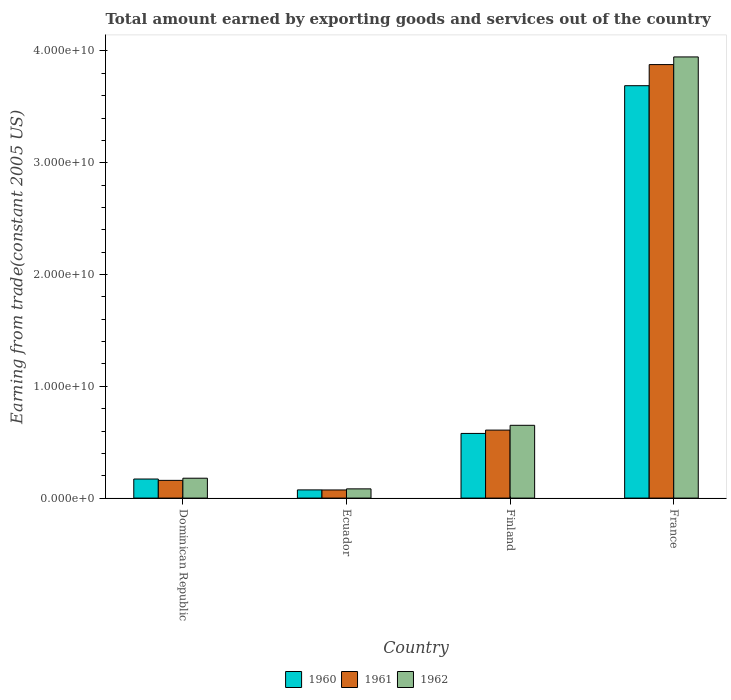How many groups of bars are there?
Make the answer very short. 4. Are the number of bars per tick equal to the number of legend labels?
Your answer should be compact. Yes. How many bars are there on the 1st tick from the right?
Make the answer very short. 3. What is the total amount earned by exporting goods and services in 1961 in Dominican Republic?
Ensure brevity in your answer.  1.59e+09. Across all countries, what is the maximum total amount earned by exporting goods and services in 1962?
Keep it short and to the point. 3.95e+1. Across all countries, what is the minimum total amount earned by exporting goods and services in 1962?
Your answer should be very brief. 8.25e+08. In which country was the total amount earned by exporting goods and services in 1962 minimum?
Keep it short and to the point. Ecuador. What is the total total amount earned by exporting goods and services in 1961 in the graph?
Provide a succinct answer. 4.72e+1. What is the difference between the total amount earned by exporting goods and services in 1962 in Finland and that in France?
Your answer should be compact. -3.30e+1. What is the difference between the total amount earned by exporting goods and services in 1961 in Ecuador and the total amount earned by exporting goods and services in 1960 in Finland?
Provide a succinct answer. -5.06e+09. What is the average total amount earned by exporting goods and services in 1960 per country?
Your answer should be very brief. 1.13e+1. What is the difference between the total amount earned by exporting goods and services of/in 1961 and total amount earned by exporting goods and services of/in 1960 in Finland?
Offer a very short reply. 2.97e+08. In how many countries, is the total amount earned by exporting goods and services in 1960 greater than 8000000000 US$?
Give a very brief answer. 1. What is the ratio of the total amount earned by exporting goods and services in 1962 in Dominican Republic to that in France?
Make the answer very short. 0.05. Is the difference between the total amount earned by exporting goods and services in 1961 in Dominican Republic and Finland greater than the difference between the total amount earned by exporting goods and services in 1960 in Dominican Republic and Finland?
Offer a terse response. No. What is the difference between the highest and the second highest total amount earned by exporting goods and services in 1960?
Offer a very short reply. -3.52e+1. What is the difference between the highest and the lowest total amount earned by exporting goods and services in 1960?
Your answer should be very brief. 3.62e+1. In how many countries, is the total amount earned by exporting goods and services in 1960 greater than the average total amount earned by exporting goods and services in 1960 taken over all countries?
Offer a very short reply. 1. Is the sum of the total amount earned by exporting goods and services in 1961 in Finland and France greater than the maximum total amount earned by exporting goods and services in 1960 across all countries?
Make the answer very short. Yes. What does the 1st bar from the left in Finland represents?
Provide a short and direct response. 1960. How many bars are there?
Make the answer very short. 12. Are all the bars in the graph horizontal?
Provide a succinct answer. No. Are the values on the major ticks of Y-axis written in scientific E-notation?
Keep it short and to the point. Yes. Does the graph contain grids?
Your answer should be compact. No. What is the title of the graph?
Your answer should be compact. Total amount earned by exporting goods and services out of the country. What is the label or title of the Y-axis?
Offer a very short reply. Earning from trade(constant 2005 US). What is the Earning from trade(constant 2005 US) of 1960 in Dominican Republic?
Offer a terse response. 1.71e+09. What is the Earning from trade(constant 2005 US) in 1961 in Dominican Republic?
Your answer should be compact. 1.59e+09. What is the Earning from trade(constant 2005 US) in 1962 in Dominican Republic?
Give a very brief answer. 1.78e+09. What is the Earning from trade(constant 2005 US) in 1960 in Ecuador?
Your answer should be compact. 7.33e+08. What is the Earning from trade(constant 2005 US) of 1961 in Ecuador?
Ensure brevity in your answer.  7.28e+08. What is the Earning from trade(constant 2005 US) in 1962 in Ecuador?
Your answer should be compact. 8.25e+08. What is the Earning from trade(constant 2005 US) in 1960 in Finland?
Your response must be concise. 5.78e+09. What is the Earning from trade(constant 2005 US) in 1961 in Finland?
Your response must be concise. 6.08e+09. What is the Earning from trade(constant 2005 US) in 1962 in Finland?
Provide a short and direct response. 6.51e+09. What is the Earning from trade(constant 2005 US) of 1960 in France?
Your answer should be compact. 3.69e+1. What is the Earning from trade(constant 2005 US) of 1961 in France?
Your answer should be very brief. 3.88e+1. What is the Earning from trade(constant 2005 US) in 1962 in France?
Offer a terse response. 3.95e+1. Across all countries, what is the maximum Earning from trade(constant 2005 US) in 1960?
Ensure brevity in your answer.  3.69e+1. Across all countries, what is the maximum Earning from trade(constant 2005 US) of 1961?
Your answer should be compact. 3.88e+1. Across all countries, what is the maximum Earning from trade(constant 2005 US) in 1962?
Ensure brevity in your answer.  3.95e+1. Across all countries, what is the minimum Earning from trade(constant 2005 US) of 1960?
Your response must be concise. 7.33e+08. Across all countries, what is the minimum Earning from trade(constant 2005 US) in 1961?
Offer a very short reply. 7.28e+08. Across all countries, what is the minimum Earning from trade(constant 2005 US) of 1962?
Make the answer very short. 8.25e+08. What is the total Earning from trade(constant 2005 US) of 1960 in the graph?
Provide a succinct answer. 4.51e+1. What is the total Earning from trade(constant 2005 US) of 1961 in the graph?
Your response must be concise. 4.72e+1. What is the total Earning from trade(constant 2005 US) of 1962 in the graph?
Your response must be concise. 4.86e+1. What is the difference between the Earning from trade(constant 2005 US) of 1960 in Dominican Republic and that in Ecuador?
Make the answer very short. 9.74e+08. What is the difference between the Earning from trade(constant 2005 US) of 1961 in Dominican Republic and that in Ecuador?
Keep it short and to the point. 8.59e+08. What is the difference between the Earning from trade(constant 2005 US) of 1962 in Dominican Republic and that in Ecuador?
Your answer should be very brief. 9.54e+08. What is the difference between the Earning from trade(constant 2005 US) of 1960 in Dominican Republic and that in Finland?
Offer a very short reply. -4.08e+09. What is the difference between the Earning from trade(constant 2005 US) in 1961 in Dominican Republic and that in Finland?
Provide a short and direct response. -4.50e+09. What is the difference between the Earning from trade(constant 2005 US) of 1962 in Dominican Republic and that in Finland?
Offer a very short reply. -4.73e+09. What is the difference between the Earning from trade(constant 2005 US) of 1960 in Dominican Republic and that in France?
Provide a succinct answer. -3.52e+1. What is the difference between the Earning from trade(constant 2005 US) in 1961 in Dominican Republic and that in France?
Your answer should be compact. -3.72e+1. What is the difference between the Earning from trade(constant 2005 US) of 1962 in Dominican Republic and that in France?
Keep it short and to the point. -3.77e+1. What is the difference between the Earning from trade(constant 2005 US) in 1960 in Ecuador and that in Finland?
Your response must be concise. -5.05e+09. What is the difference between the Earning from trade(constant 2005 US) in 1961 in Ecuador and that in Finland?
Make the answer very short. -5.35e+09. What is the difference between the Earning from trade(constant 2005 US) in 1962 in Ecuador and that in Finland?
Your answer should be compact. -5.69e+09. What is the difference between the Earning from trade(constant 2005 US) of 1960 in Ecuador and that in France?
Your answer should be compact. -3.62e+1. What is the difference between the Earning from trade(constant 2005 US) of 1961 in Ecuador and that in France?
Provide a succinct answer. -3.81e+1. What is the difference between the Earning from trade(constant 2005 US) of 1962 in Ecuador and that in France?
Your answer should be very brief. -3.86e+1. What is the difference between the Earning from trade(constant 2005 US) in 1960 in Finland and that in France?
Your answer should be compact. -3.11e+1. What is the difference between the Earning from trade(constant 2005 US) in 1961 in Finland and that in France?
Ensure brevity in your answer.  -3.27e+1. What is the difference between the Earning from trade(constant 2005 US) in 1962 in Finland and that in France?
Your answer should be compact. -3.30e+1. What is the difference between the Earning from trade(constant 2005 US) of 1960 in Dominican Republic and the Earning from trade(constant 2005 US) of 1961 in Ecuador?
Your answer should be compact. 9.79e+08. What is the difference between the Earning from trade(constant 2005 US) in 1960 in Dominican Republic and the Earning from trade(constant 2005 US) in 1962 in Ecuador?
Give a very brief answer. 8.81e+08. What is the difference between the Earning from trade(constant 2005 US) of 1961 in Dominican Republic and the Earning from trade(constant 2005 US) of 1962 in Ecuador?
Ensure brevity in your answer.  7.61e+08. What is the difference between the Earning from trade(constant 2005 US) of 1960 in Dominican Republic and the Earning from trade(constant 2005 US) of 1961 in Finland?
Your answer should be compact. -4.38e+09. What is the difference between the Earning from trade(constant 2005 US) of 1960 in Dominican Republic and the Earning from trade(constant 2005 US) of 1962 in Finland?
Your answer should be compact. -4.81e+09. What is the difference between the Earning from trade(constant 2005 US) of 1961 in Dominican Republic and the Earning from trade(constant 2005 US) of 1962 in Finland?
Make the answer very short. -4.93e+09. What is the difference between the Earning from trade(constant 2005 US) in 1960 in Dominican Republic and the Earning from trade(constant 2005 US) in 1961 in France?
Provide a short and direct response. -3.71e+1. What is the difference between the Earning from trade(constant 2005 US) of 1960 in Dominican Republic and the Earning from trade(constant 2005 US) of 1962 in France?
Offer a terse response. -3.78e+1. What is the difference between the Earning from trade(constant 2005 US) in 1961 in Dominican Republic and the Earning from trade(constant 2005 US) in 1962 in France?
Your response must be concise. -3.79e+1. What is the difference between the Earning from trade(constant 2005 US) in 1960 in Ecuador and the Earning from trade(constant 2005 US) in 1961 in Finland?
Keep it short and to the point. -5.35e+09. What is the difference between the Earning from trade(constant 2005 US) in 1960 in Ecuador and the Earning from trade(constant 2005 US) in 1962 in Finland?
Make the answer very short. -5.78e+09. What is the difference between the Earning from trade(constant 2005 US) in 1961 in Ecuador and the Earning from trade(constant 2005 US) in 1962 in Finland?
Your answer should be compact. -5.78e+09. What is the difference between the Earning from trade(constant 2005 US) in 1960 in Ecuador and the Earning from trade(constant 2005 US) in 1961 in France?
Your response must be concise. -3.81e+1. What is the difference between the Earning from trade(constant 2005 US) of 1960 in Ecuador and the Earning from trade(constant 2005 US) of 1962 in France?
Make the answer very short. -3.87e+1. What is the difference between the Earning from trade(constant 2005 US) in 1961 in Ecuador and the Earning from trade(constant 2005 US) in 1962 in France?
Your response must be concise. -3.87e+1. What is the difference between the Earning from trade(constant 2005 US) of 1960 in Finland and the Earning from trade(constant 2005 US) of 1961 in France?
Offer a terse response. -3.30e+1. What is the difference between the Earning from trade(constant 2005 US) in 1960 in Finland and the Earning from trade(constant 2005 US) in 1962 in France?
Provide a short and direct response. -3.37e+1. What is the difference between the Earning from trade(constant 2005 US) in 1961 in Finland and the Earning from trade(constant 2005 US) in 1962 in France?
Make the answer very short. -3.34e+1. What is the average Earning from trade(constant 2005 US) in 1960 per country?
Ensure brevity in your answer.  1.13e+1. What is the average Earning from trade(constant 2005 US) in 1961 per country?
Offer a terse response. 1.18e+1. What is the average Earning from trade(constant 2005 US) in 1962 per country?
Your answer should be compact. 1.21e+1. What is the difference between the Earning from trade(constant 2005 US) in 1960 and Earning from trade(constant 2005 US) in 1961 in Dominican Republic?
Ensure brevity in your answer.  1.20e+08. What is the difference between the Earning from trade(constant 2005 US) in 1960 and Earning from trade(constant 2005 US) in 1962 in Dominican Republic?
Offer a terse response. -7.23e+07. What is the difference between the Earning from trade(constant 2005 US) of 1961 and Earning from trade(constant 2005 US) of 1962 in Dominican Republic?
Offer a terse response. -1.92e+08. What is the difference between the Earning from trade(constant 2005 US) in 1960 and Earning from trade(constant 2005 US) in 1961 in Ecuador?
Offer a very short reply. 5.42e+06. What is the difference between the Earning from trade(constant 2005 US) of 1960 and Earning from trade(constant 2005 US) of 1962 in Ecuador?
Your answer should be very brief. -9.21e+07. What is the difference between the Earning from trade(constant 2005 US) of 1961 and Earning from trade(constant 2005 US) of 1962 in Ecuador?
Provide a succinct answer. -9.75e+07. What is the difference between the Earning from trade(constant 2005 US) of 1960 and Earning from trade(constant 2005 US) of 1961 in Finland?
Ensure brevity in your answer.  -2.97e+08. What is the difference between the Earning from trade(constant 2005 US) of 1960 and Earning from trade(constant 2005 US) of 1962 in Finland?
Provide a short and direct response. -7.27e+08. What is the difference between the Earning from trade(constant 2005 US) of 1961 and Earning from trade(constant 2005 US) of 1962 in Finland?
Your answer should be compact. -4.30e+08. What is the difference between the Earning from trade(constant 2005 US) in 1960 and Earning from trade(constant 2005 US) in 1961 in France?
Your answer should be very brief. -1.89e+09. What is the difference between the Earning from trade(constant 2005 US) in 1960 and Earning from trade(constant 2005 US) in 1962 in France?
Make the answer very short. -2.57e+09. What is the difference between the Earning from trade(constant 2005 US) in 1961 and Earning from trade(constant 2005 US) in 1962 in France?
Provide a short and direct response. -6.85e+08. What is the ratio of the Earning from trade(constant 2005 US) of 1960 in Dominican Republic to that in Ecuador?
Provide a short and direct response. 2.33. What is the ratio of the Earning from trade(constant 2005 US) of 1961 in Dominican Republic to that in Ecuador?
Keep it short and to the point. 2.18. What is the ratio of the Earning from trade(constant 2005 US) in 1962 in Dominican Republic to that in Ecuador?
Make the answer very short. 2.16. What is the ratio of the Earning from trade(constant 2005 US) in 1960 in Dominican Republic to that in Finland?
Your answer should be compact. 0.29. What is the ratio of the Earning from trade(constant 2005 US) of 1961 in Dominican Republic to that in Finland?
Keep it short and to the point. 0.26. What is the ratio of the Earning from trade(constant 2005 US) in 1962 in Dominican Republic to that in Finland?
Your answer should be very brief. 0.27. What is the ratio of the Earning from trade(constant 2005 US) of 1960 in Dominican Republic to that in France?
Your response must be concise. 0.05. What is the ratio of the Earning from trade(constant 2005 US) of 1961 in Dominican Republic to that in France?
Your answer should be very brief. 0.04. What is the ratio of the Earning from trade(constant 2005 US) in 1962 in Dominican Republic to that in France?
Offer a very short reply. 0.05. What is the ratio of the Earning from trade(constant 2005 US) of 1960 in Ecuador to that in Finland?
Your response must be concise. 0.13. What is the ratio of the Earning from trade(constant 2005 US) in 1961 in Ecuador to that in Finland?
Your answer should be compact. 0.12. What is the ratio of the Earning from trade(constant 2005 US) in 1962 in Ecuador to that in Finland?
Provide a succinct answer. 0.13. What is the ratio of the Earning from trade(constant 2005 US) in 1960 in Ecuador to that in France?
Make the answer very short. 0.02. What is the ratio of the Earning from trade(constant 2005 US) of 1961 in Ecuador to that in France?
Keep it short and to the point. 0.02. What is the ratio of the Earning from trade(constant 2005 US) in 1962 in Ecuador to that in France?
Give a very brief answer. 0.02. What is the ratio of the Earning from trade(constant 2005 US) in 1960 in Finland to that in France?
Provide a succinct answer. 0.16. What is the ratio of the Earning from trade(constant 2005 US) of 1961 in Finland to that in France?
Your answer should be very brief. 0.16. What is the ratio of the Earning from trade(constant 2005 US) of 1962 in Finland to that in France?
Offer a very short reply. 0.17. What is the difference between the highest and the second highest Earning from trade(constant 2005 US) of 1960?
Your answer should be compact. 3.11e+1. What is the difference between the highest and the second highest Earning from trade(constant 2005 US) of 1961?
Provide a succinct answer. 3.27e+1. What is the difference between the highest and the second highest Earning from trade(constant 2005 US) of 1962?
Provide a short and direct response. 3.30e+1. What is the difference between the highest and the lowest Earning from trade(constant 2005 US) of 1960?
Offer a very short reply. 3.62e+1. What is the difference between the highest and the lowest Earning from trade(constant 2005 US) in 1961?
Your response must be concise. 3.81e+1. What is the difference between the highest and the lowest Earning from trade(constant 2005 US) in 1962?
Offer a terse response. 3.86e+1. 